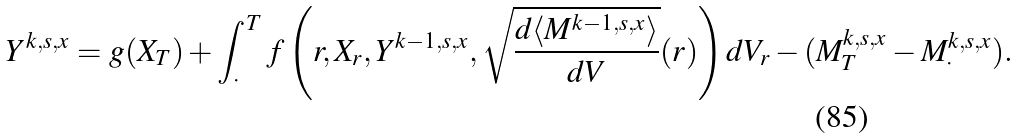Convert formula to latex. <formula><loc_0><loc_0><loc_500><loc_500>Y ^ { k , s , x } = g ( X _ { T } ) + \int _ { \cdot } ^ { T } f \left ( r , X _ { r } , Y ^ { k - 1 , s , x } , \sqrt { \frac { d \langle M ^ { k - 1 , s , x } \rangle } { d V } } ( r ) \right ) d V _ { r } - ( M ^ { k , s , x } _ { T } - M ^ { k , s , x } _ { \cdot } ) .</formula> 